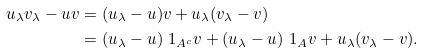Convert formula to latex. <formula><loc_0><loc_0><loc_500><loc_500>u _ { \lambda } v _ { \lambda } - u v & = ( u _ { \lambda } - u ) v + u _ { \lambda } ( v _ { \lambda } - v ) \\ & = ( u _ { \lambda } - u ) \ 1 _ { A ^ { c } } v + ( u _ { \lambda } - u ) \ 1 _ { A } v + u _ { \lambda } ( v _ { \lambda } - v ) .</formula> 